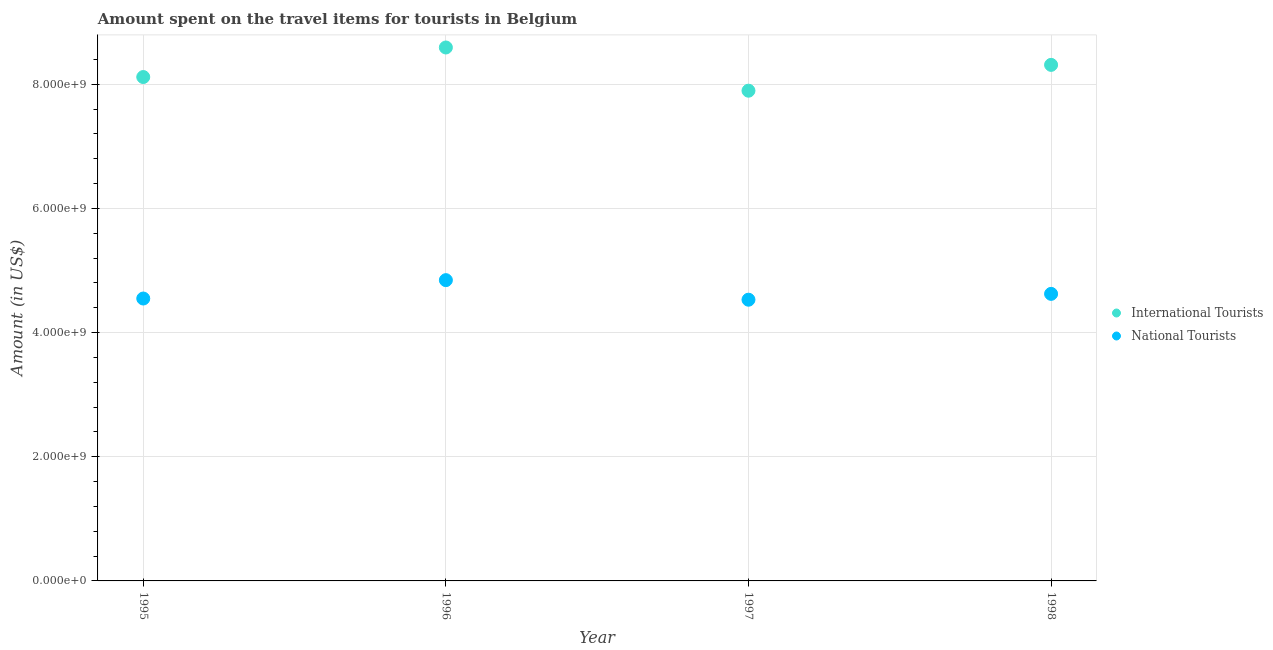How many different coloured dotlines are there?
Offer a terse response. 2. Is the number of dotlines equal to the number of legend labels?
Your answer should be compact. Yes. What is the amount spent on travel items of international tourists in 1995?
Make the answer very short. 8.12e+09. Across all years, what is the maximum amount spent on travel items of international tourists?
Make the answer very short. 8.59e+09. Across all years, what is the minimum amount spent on travel items of international tourists?
Your answer should be very brief. 7.90e+09. What is the total amount spent on travel items of national tourists in the graph?
Make the answer very short. 1.85e+1. What is the difference between the amount spent on travel items of international tourists in 1995 and that in 1996?
Your answer should be very brief. -4.76e+08. What is the difference between the amount spent on travel items of international tourists in 1996 and the amount spent on travel items of national tourists in 1998?
Offer a terse response. 3.97e+09. What is the average amount spent on travel items of national tourists per year?
Your response must be concise. 4.64e+09. In the year 1995, what is the difference between the amount spent on travel items of national tourists and amount spent on travel items of international tourists?
Your answer should be very brief. -3.57e+09. In how many years, is the amount spent on travel items of national tourists greater than 1200000000 US$?
Your response must be concise. 4. What is the ratio of the amount spent on travel items of national tourists in 1995 to that in 1997?
Your response must be concise. 1. Is the amount spent on travel items of international tourists in 1995 less than that in 1998?
Offer a terse response. Yes. What is the difference between the highest and the second highest amount spent on travel items of international tourists?
Your answer should be very brief. 2.80e+08. What is the difference between the highest and the lowest amount spent on travel items of international tourists?
Make the answer very short. 6.96e+08. Is the sum of the amount spent on travel items of international tourists in 1995 and 1997 greater than the maximum amount spent on travel items of national tourists across all years?
Keep it short and to the point. Yes. Does the amount spent on travel items of national tourists monotonically increase over the years?
Offer a very short reply. No. How many years are there in the graph?
Provide a short and direct response. 4. What is the difference between two consecutive major ticks on the Y-axis?
Ensure brevity in your answer.  2.00e+09. Does the graph contain any zero values?
Offer a terse response. No. Where does the legend appear in the graph?
Ensure brevity in your answer.  Center right. How are the legend labels stacked?
Your answer should be very brief. Vertical. What is the title of the graph?
Your answer should be compact. Amount spent on the travel items for tourists in Belgium. Does "Techinal cooperation" appear as one of the legend labels in the graph?
Provide a short and direct response. No. What is the Amount (in US$) of International Tourists in 1995?
Keep it short and to the point. 8.12e+09. What is the Amount (in US$) in National Tourists in 1995?
Provide a short and direct response. 4.55e+09. What is the Amount (in US$) in International Tourists in 1996?
Offer a terse response. 8.59e+09. What is the Amount (in US$) of National Tourists in 1996?
Give a very brief answer. 4.84e+09. What is the Amount (in US$) in International Tourists in 1997?
Provide a succinct answer. 7.90e+09. What is the Amount (in US$) of National Tourists in 1997?
Keep it short and to the point. 4.53e+09. What is the Amount (in US$) of International Tourists in 1998?
Offer a very short reply. 8.31e+09. What is the Amount (in US$) of National Tourists in 1998?
Give a very brief answer. 4.62e+09. Across all years, what is the maximum Amount (in US$) of International Tourists?
Make the answer very short. 8.59e+09. Across all years, what is the maximum Amount (in US$) of National Tourists?
Ensure brevity in your answer.  4.84e+09. Across all years, what is the minimum Amount (in US$) in International Tourists?
Provide a succinct answer. 7.90e+09. Across all years, what is the minimum Amount (in US$) of National Tourists?
Provide a short and direct response. 4.53e+09. What is the total Amount (in US$) in International Tourists in the graph?
Make the answer very short. 3.29e+1. What is the total Amount (in US$) of National Tourists in the graph?
Your answer should be compact. 1.85e+1. What is the difference between the Amount (in US$) in International Tourists in 1995 and that in 1996?
Keep it short and to the point. -4.76e+08. What is the difference between the Amount (in US$) in National Tourists in 1995 and that in 1996?
Make the answer very short. -2.96e+08. What is the difference between the Amount (in US$) in International Tourists in 1995 and that in 1997?
Offer a very short reply. 2.20e+08. What is the difference between the Amount (in US$) of National Tourists in 1995 and that in 1997?
Offer a terse response. 1.90e+07. What is the difference between the Amount (in US$) of International Tourists in 1995 and that in 1998?
Give a very brief answer. -1.96e+08. What is the difference between the Amount (in US$) of National Tourists in 1995 and that in 1998?
Give a very brief answer. -7.50e+07. What is the difference between the Amount (in US$) of International Tourists in 1996 and that in 1997?
Your answer should be compact. 6.96e+08. What is the difference between the Amount (in US$) in National Tourists in 1996 and that in 1997?
Give a very brief answer. 3.15e+08. What is the difference between the Amount (in US$) in International Tourists in 1996 and that in 1998?
Your answer should be compact. 2.80e+08. What is the difference between the Amount (in US$) in National Tourists in 1996 and that in 1998?
Provide a short and direct response. 2.21e+08. What is the difference between the Amount (in US$) in International Tourists in 1997 and that in 1998?
Ensure brevity in your answer.  -4.16e+08. What is the difference between the Amount (in US$) of National Tourists in 1997 and that in 1998?
Your response must be concise. -9.40e+07. What is the difference between the Amount (in US$) of International Tourists in 1995 and the Amount (in US$) of National Tourists in 1996?
Provide a succinct answer. 3.27e+09. What is the difference between the Amount (in US$) of International Tourists in 1995 and the Amount (in US$) of National Tourists in 1997?
Your answer should be very brief. 3.59e+09. What is the difference between the Amount (in US$) of International Tourists in 1995 and the Amount (in US$) of National Tourists in 1998?
Your response must be concise. 3.49e+09. What is the difference between the Amount (in US$) of International Tourists in 1996 and the Amount (in US$) of National Tourists in 1997?
Give a very brief answer. 4.06e+09. What is the difference between the Amount (in US$) in International Tourists in 1996 and the Amount (in US$) in National Tourists in 1998?
Your answer should be compact. 3.97e+09. What is the difference between the Amount (in US$) of International Tourists in 1997 and the Amount (in US$) of National Tourists in 1998?
Keep it short and to the point. 3.27e+09. What is the average Amount (in US$) in International Tourists per year?
Make the answer very short. 8.23e+09. What is the average Amount (in US$) of National Tourists per year?
Keep it short and to the point. 4.64e+09. In the year 1995, what is the difference between the Amount (in US$) in International Tourists and Amount (in US$) in National Tourists?
Offer a terse response. 3.57e+09. In the year 1996, what is the difference between the Amount (in US$) of International Tourists and Amount (in US$) of National Tourists?
Ensure brevity in your answer.  3.75e+09. In the year 1997, what is the difference between the Amount (in US$) in International Tourists and Amount (in US$) in National Tourists?
Make the answer very short. 3.37e+09. In the year 1998, what is the difference between the Amount (in US$) in International Tourists and Amount (in US$) in National Tourists?
Ensure brevity in your answer.  3.69e+09. What is the ratio of the Amount (in US$) of International Tourists in 1995 to that in 1996?
Make the answer very short. 0.94. What is the ratio of the Amount (in US$) in National Tourists in 1995 to that in 1996?
Offer a very short reply. 0.94. What is the ratio of the Amount (in US$) in International Tourists in 1995 to that in 1997?
Offer a terse response. 1.03. What is the ratio of the Amount (in US$) of National Tourists in 1995 to that in 1997?
Keep it short and to the point. 1. What is the ratio of the Amount (in US$) in International Tourists in 1995 to that in 1998?
Offer a very short reply. 0.98. What is the ratio of the Amount (in US$) of National Tourists in 1995 to that in 1998?
Provide a succinct answer. 0.98. What is the ratio of the Amount (in US$) of International Tourists in 1996 to that in 1997?
Your response must be concise. 1.09. What is the ratio of the Amount (in US$) in National Tourists in 1996 to that in 1997?
Your response must be concise. 1.07. What is the ratio of the Amount (in US$) in International Tourists in 1996 to that in 1998?
Your response must be concise. 1.03. What is the ratio of the Amount (in US$) of National Tourists in 1996 to that in 1998?
Give a very brief answer. 1.05. What is the ratio of the Amount (in US$) in International Tourists in 1997 to that in 1998?
Give a very brief answer. 0.95. What is the ratio of the Amount (in US$) of National Tourists in 1997 to that in 1998?
Provide a succinct answer. 0.98. What is the difference between the highest and the second highest Amount (in US$) of International Tourists?
Offer a terse response. 2.80e+08. What is the difference between the highest and the second highest Amount (in US$) of National Tourists?
Make the answer very short. 2.21e+08. What is the difference between the highest and the lowest Amount (in US$) of International Tourists?
Make the answer very short. 6.96e+08. What is the difference between the highest and the lowest Amount (in US$) of National Tourists?
Keep it short and to the point. 3.15e+08. 